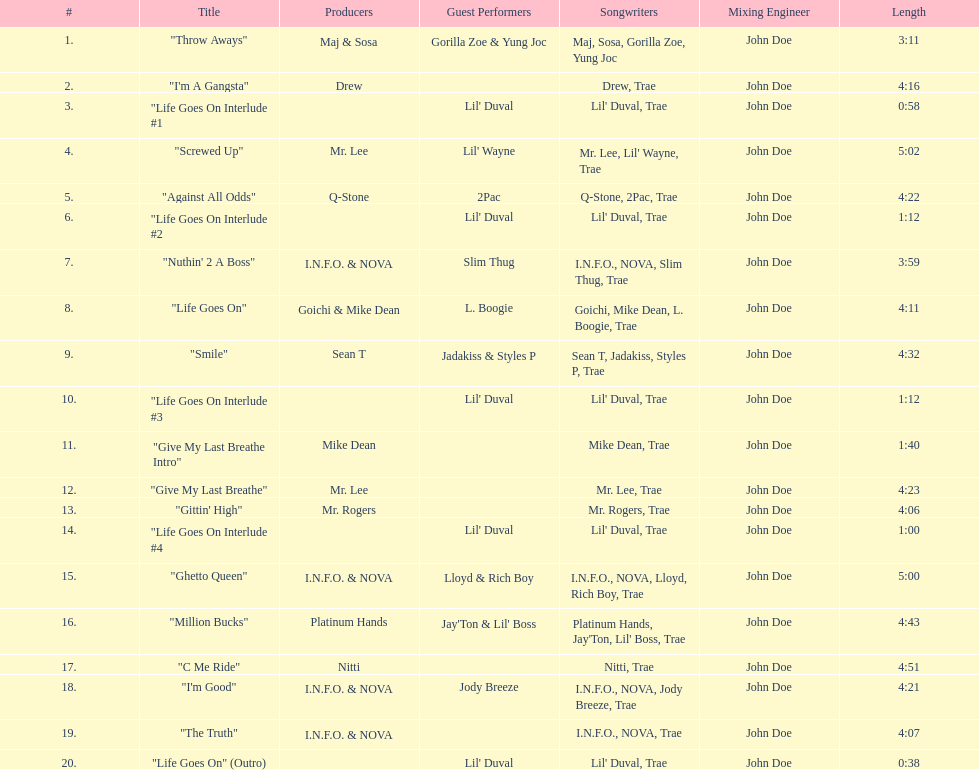What is the total number of tracks on the album? 20. 